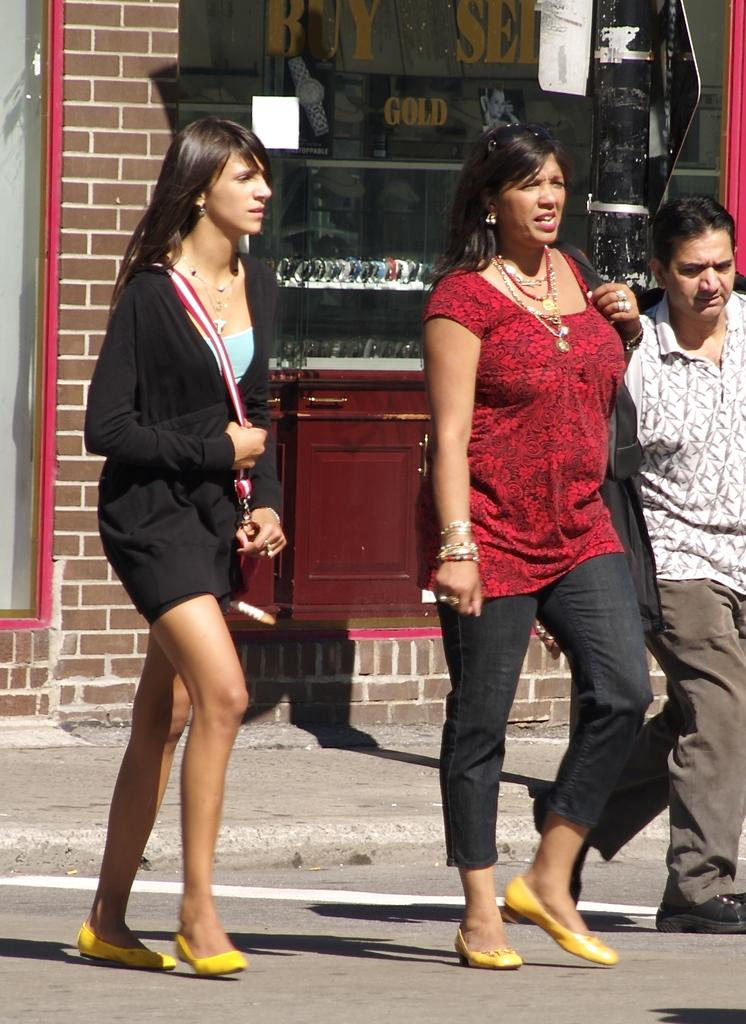What are the people in the image doing? There are persons walking in the image. Can you describe the clothing of one of the persons? One person is wearing a black dress. What can be seen in the background of the image? There is a stall in the background of the image. What is the color of the wall in the background? The wall in the background is brown. What type of appliance is being used by the person in the black dress? There is no appliance visible in the image, and the person in the black dress is not using any appliance. Can you tell me how many rakes are present in the image? There are no rakes present in the image. 